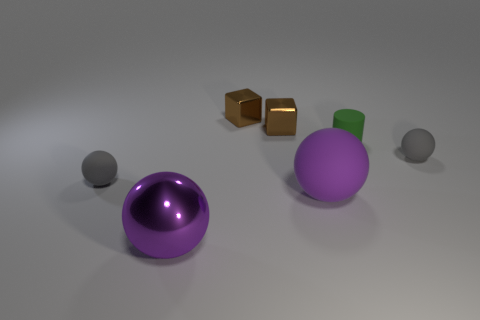Add 3 big gray things. How many objects exist? 10 Subtract all shiny spheres. How many spheres are left? 3 Subtract 0 purple cylinders. How many objects are left? 7 Subtract all cylinders. How many objects are left? 6 Subtract 2 balls. How many balls are left? 2 Subtract all cyan spheres. Subtract all brown cylinders. How many spheres are left? 4 Subtract all gray cylinders. How many gray balls are left? 2 Subtract all metal cubes. Subtract all tiny shiny blocks. How many objects are left? 3 Add 1 cylinders. How many cylinders are left? 2 Add 7 tiny matte cylinders. How many tiny matte cylinders exist? 8 